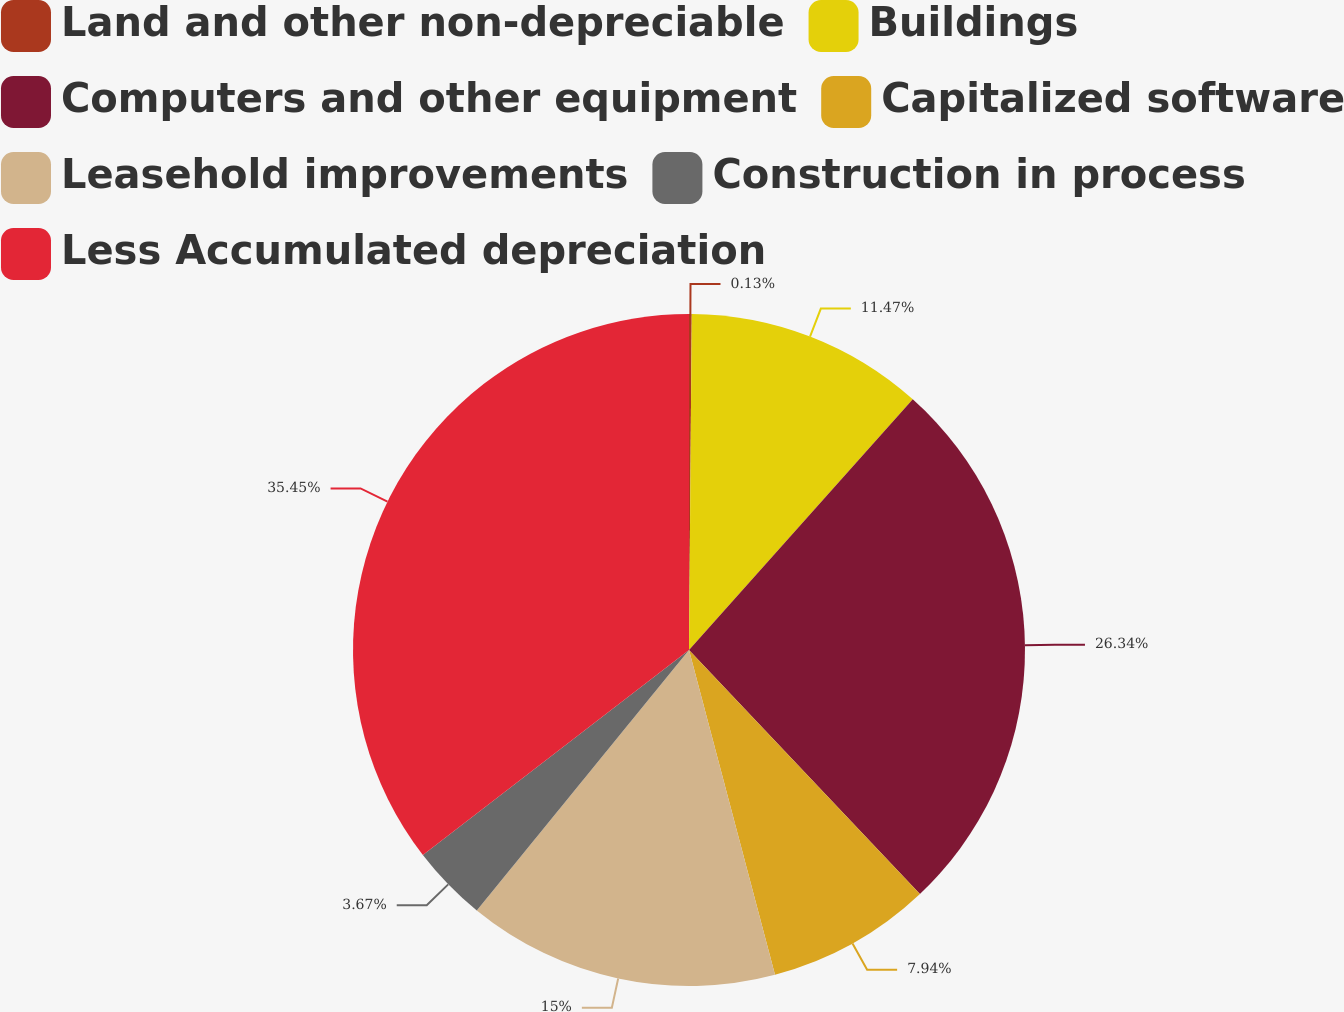Convert chart to OTSL. <chart><loc_0><loc_0><loc_500><loc_500><pie_chart><fcel>Land and other non-depreciable<fcel>Buildings<fcel>Computers and other equipment<fcel>Capitalized software<fcel>Leasehold improvements<fcel>Construction in process<fcel>Less Accumulated depreciation<nl><fcel>0.13%<fcel>11.47%<fcel>26.34%<fcel>7.94%<fcel>15.0%<fcel>3.67%<fcel>35.45%<nl></chart> 